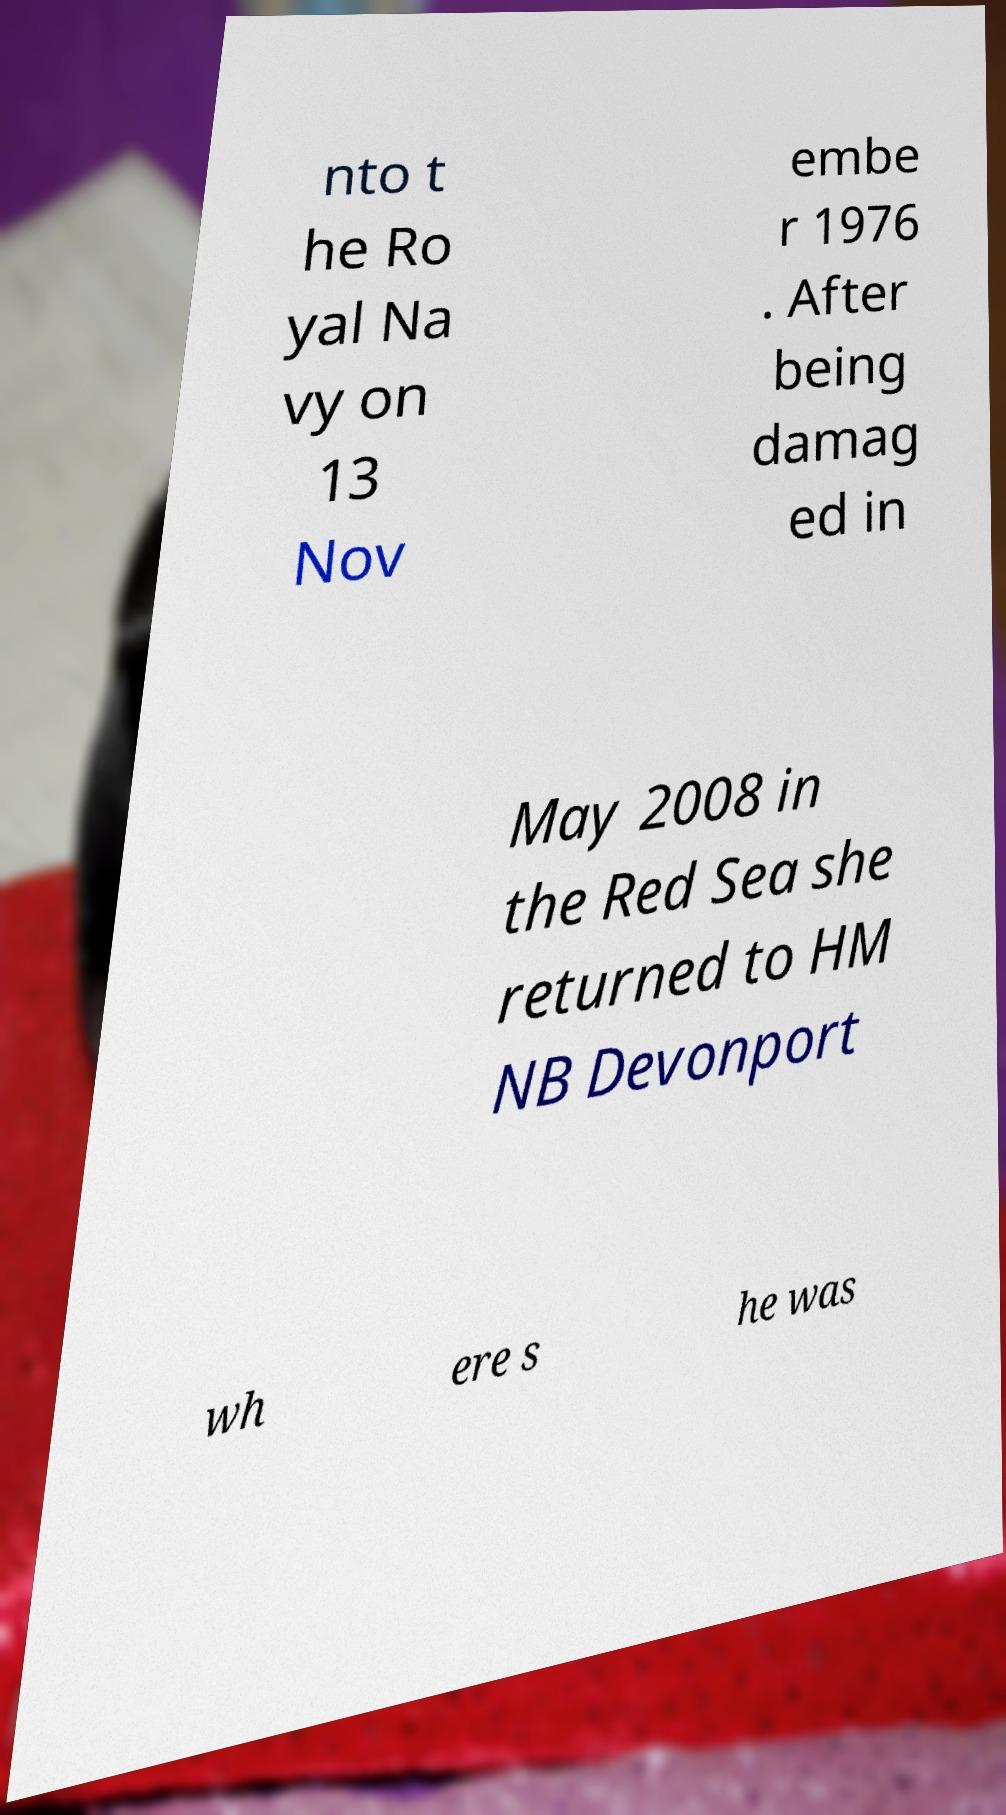Can you accurately transcribe the text from the provided image for me? nto t he Ro yal Na vy on 13 Nov embe r 1976 . After being damag ed in May 2008 in the Red Sea she returned to HM NB Devonport wh ere s he was 